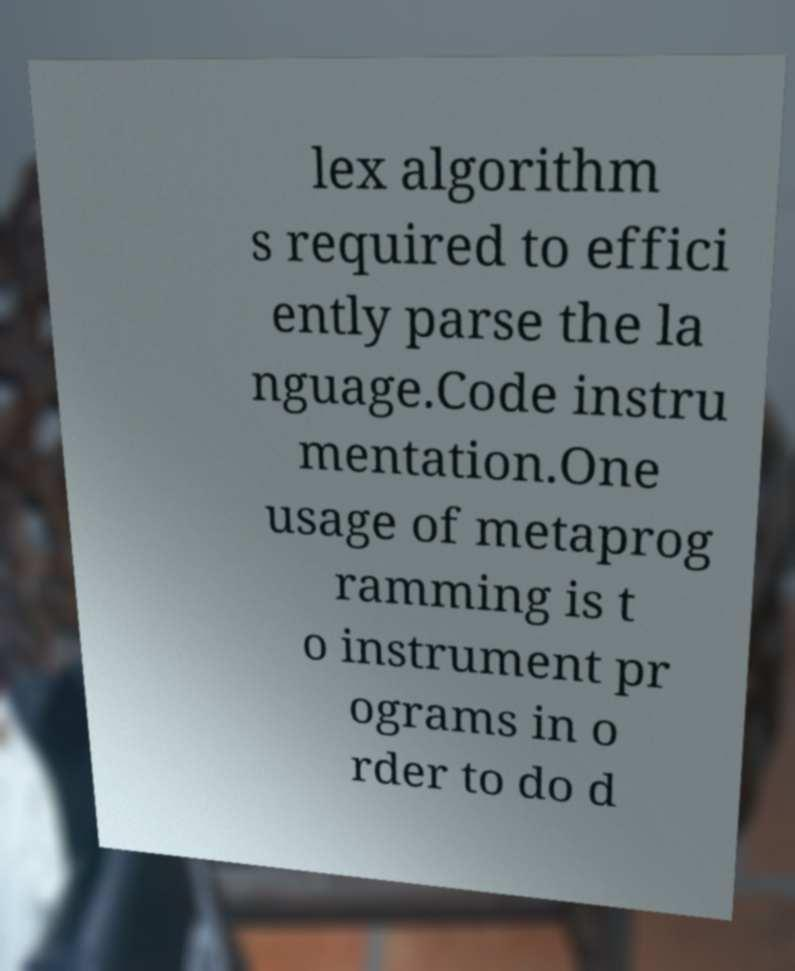I need the written content from this picture converted into text. Can you do that? lex algorithm s required to effici ently parse the la nguage.Code instru mentation.One usage of metaprog ramming is t o instrument pr ograms in o rder to do d 